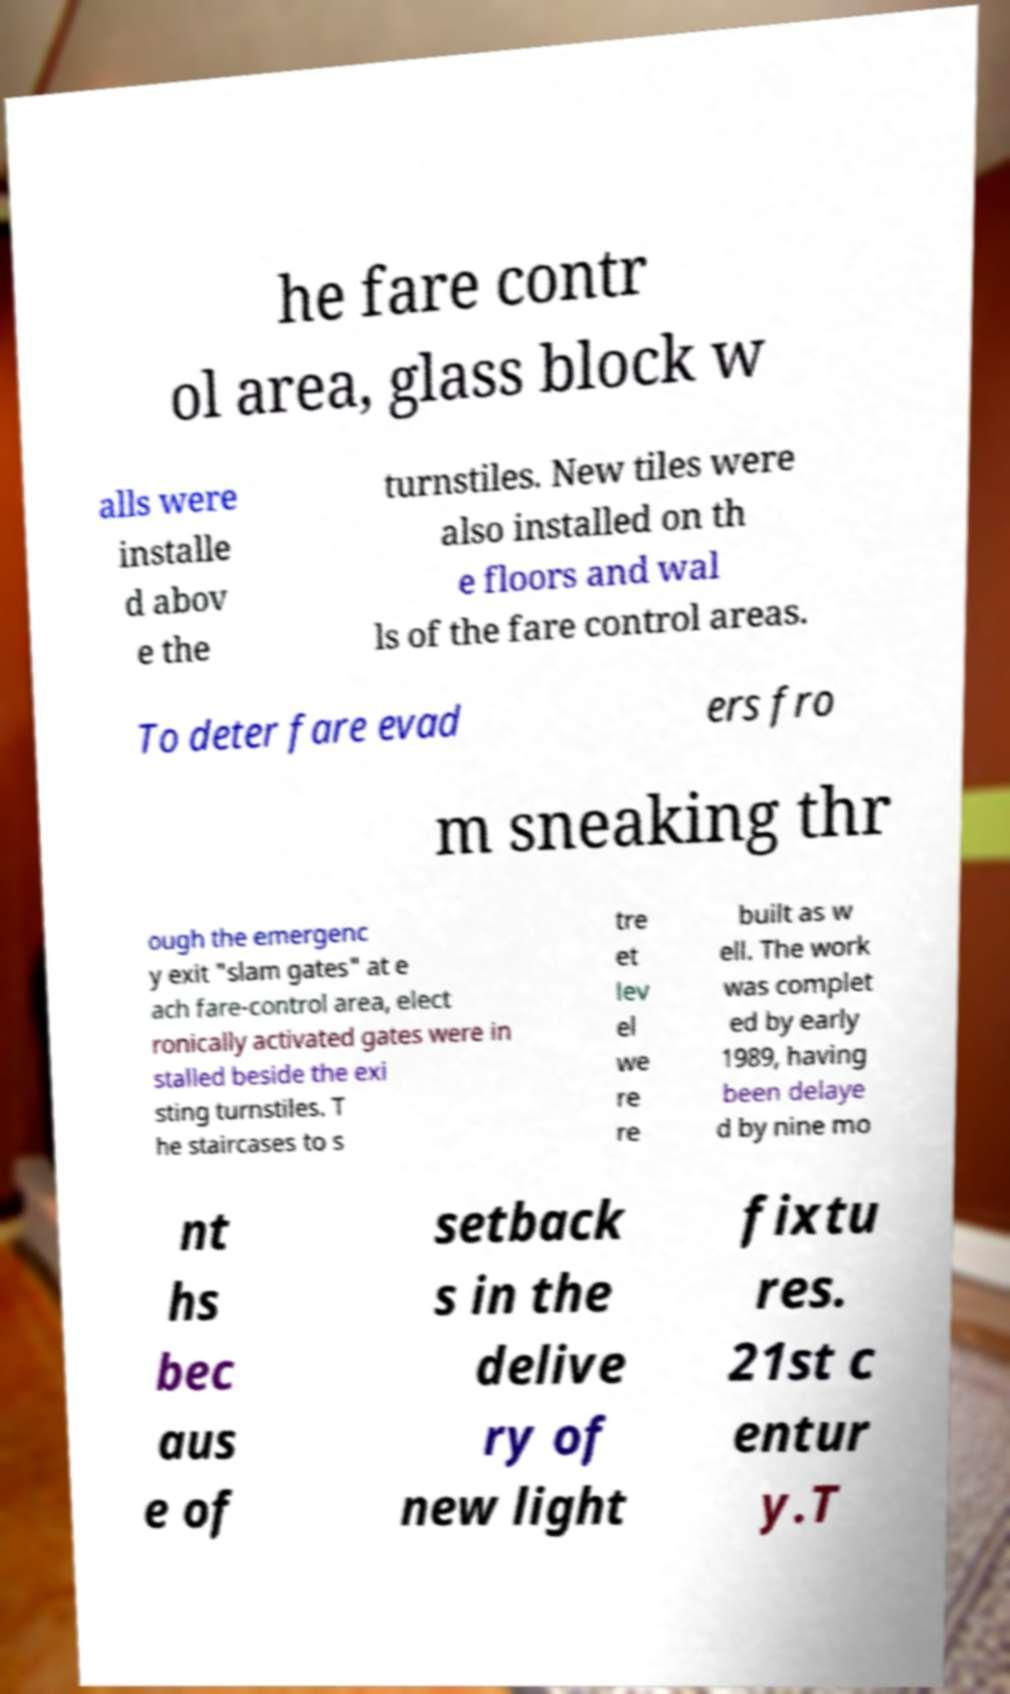For documentation purposes, I need the text within this image transcribed. Could you provide that? he fare contr ol area, glass block w alls were installe d abov e the turnstiles. New tiles were also installed on th e floors and wal ls of the fare control areas. To deter fare evad ers fro m sneaking thr ough the emergenc y exit "slam gates" at e ach fare-control area, elect ronically activated gates were in stalled beside the exi sting turnstiles. T he staircases to s tre et lev el we re re built as w ell. The work was complet ed by early 1989, having been delaye d by nine mo nt hs bec aus e of setback s in the delive ry of new light fixtu res. 21st c entur y.T 